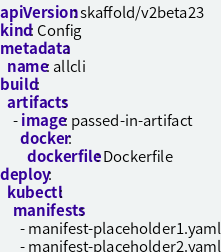<code> <loc_0><loc_0><loc_500><loc_500><_YAML_>apiVersion: skaffold/v2beta23
kind: Config
metadata:
  name: allcli
build:
  artifacts:
    - image: passed-in-artifact
      docker:
        dockerfile: Dockerfile
deploy:
  kubectl:
    manifests:
      - manifest-placeholder1.yaml
      - manifest-placeholder2.yaml
</code> 